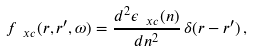<formula> <loc_0><loc_0><loc_500><loc_500>f _ { \ x c } ( { r } , { r } ^ { \prime } , \omega ) = \frac { d ^ { 2 } \epsilon _ { \ x c } ( n ) } { d n ^ { 2 } } \, \delta ( { r } - { r } ^ { \prime } ) \, ,</formula> 